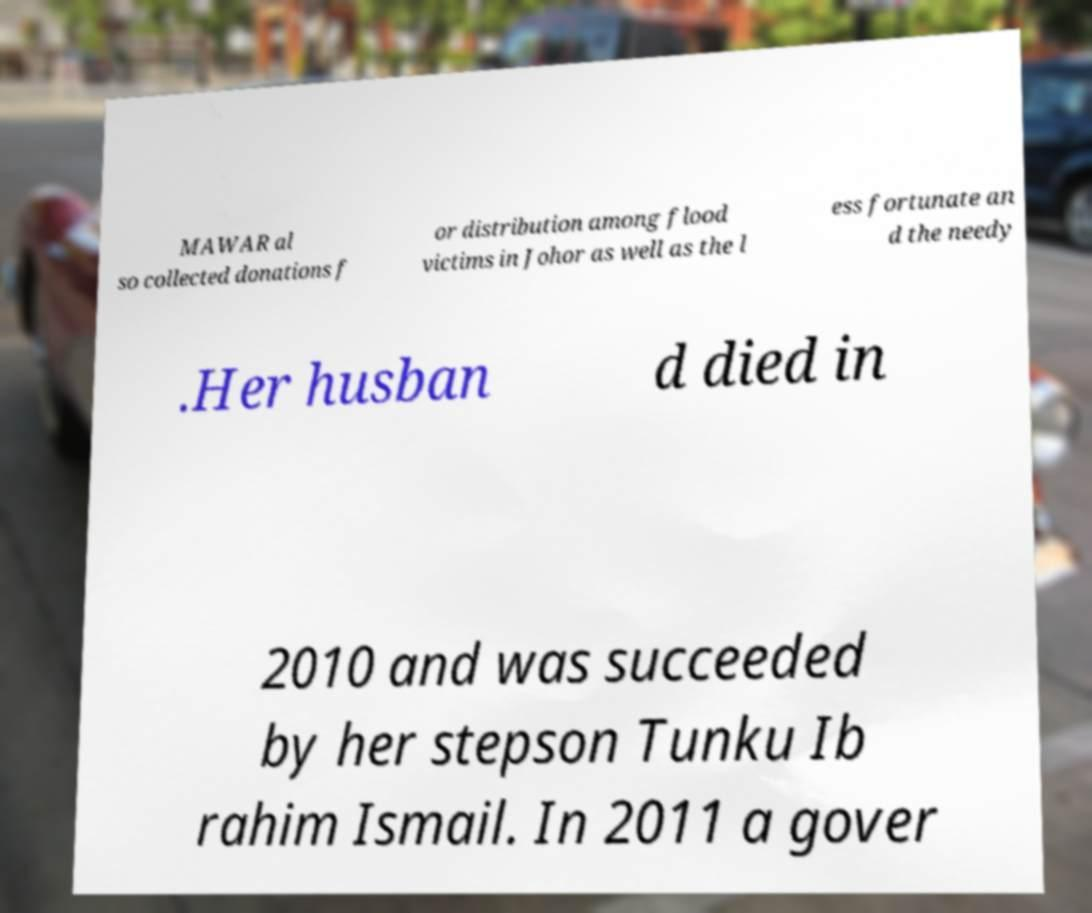Could you assist in decoding the text presented in this image and type it out clearly? MAWAR al so collected donations f or distribution among flood victims in Johor as well as the l ess fortunate an d the needy .Her husban d died in 2010 and was succeeded by her stepson Tunku Ib rahim Ismail. In 2011 a gover 